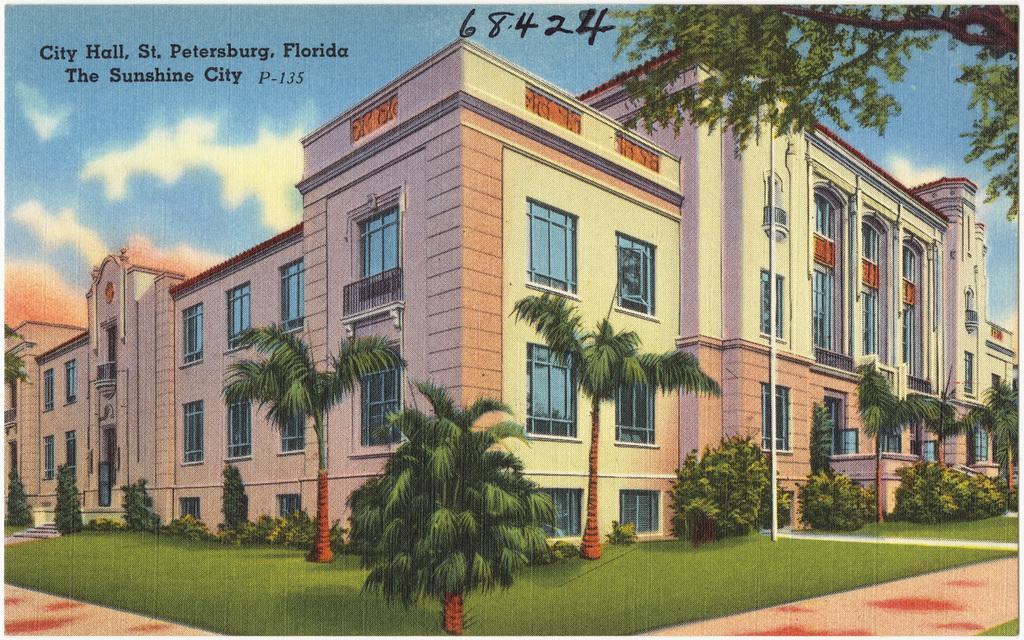Can you describe this image briefly? It is printed image,there is a city hall and around the hall there are few trees and grass and there are a lot of windows and doors to the building. 